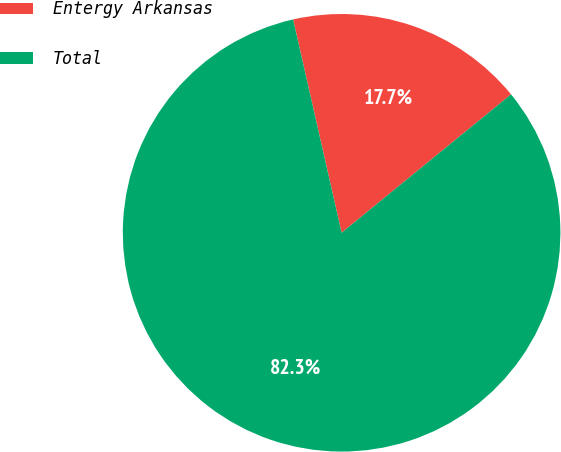Convert chart to OTSL. <chart><loc_0><loc_0><loc_500><loc_500><pie_chart><fcel>Entergy Arkansas<fcel>Total<nl><fcel>17.66%<fcel>82.34%<nl></chart> 